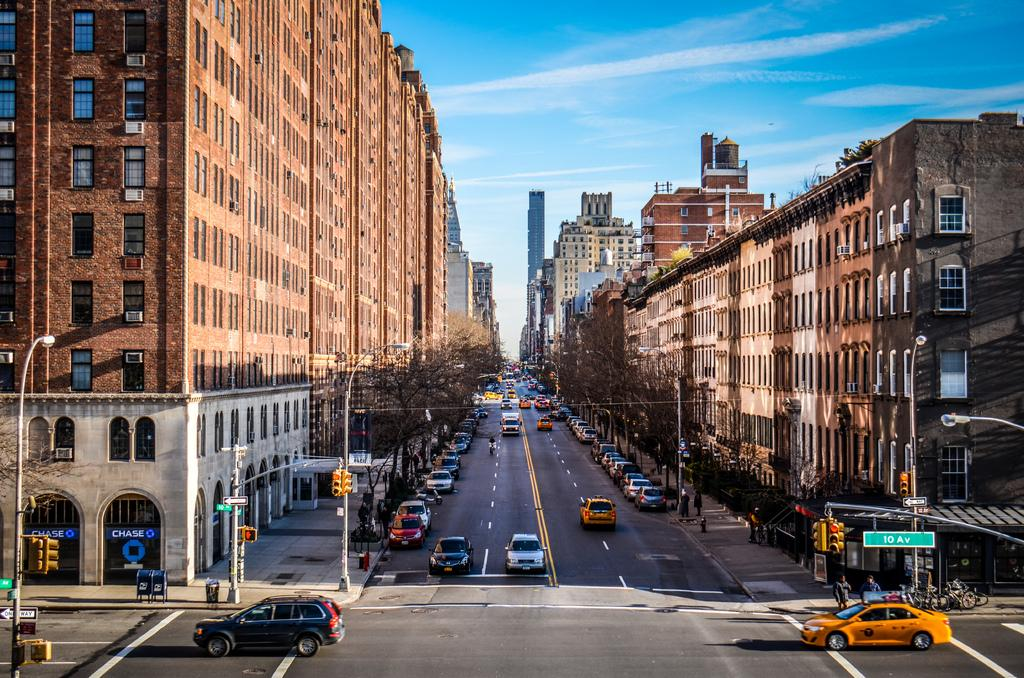<image>
Provide a brief description of the given image. A yellow taxi is entering a busy city intersection and a street sign is above it that says 10 Av. 